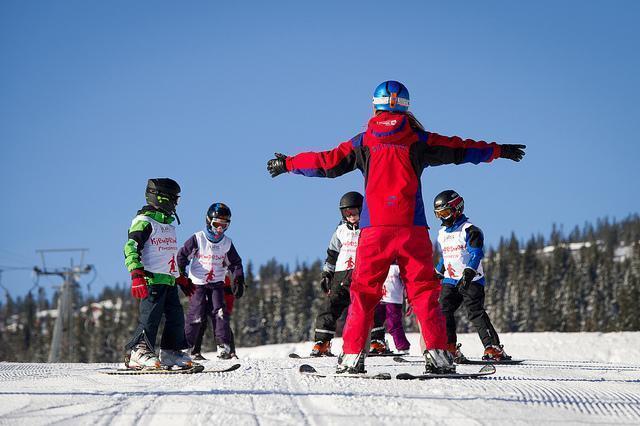What does the person in red provide?
From the following four choices, select the correct answer to address the question.
Options: Admonishments, snacks, ski lessons, grades. Ski lessons. 